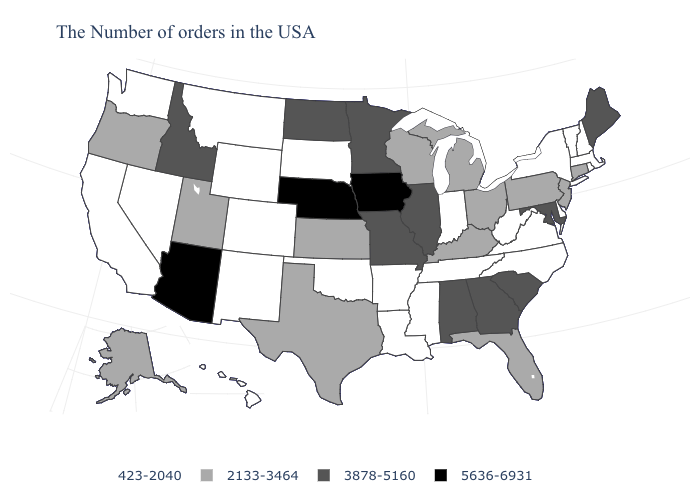What is the value of Michigan?
Answer briefly. 2133-3464. What is the value of Washington?
Write a very short answer. 423-2040. Among the states that border Utah , does Colorado have the highest value?
Concise answer only. No. Name the states that have a value in the range 2133-3464?
Quick response, please. Connecticut, New Jersey, Pennsylvania, Ohio, Florida, Michigan, Kentucky, Wisconsin, Kansas, Texas, Utah, Oregon, Alaska. Name the states that have a value in the range 423-2040?
Concise answer only. Massachusetts, Rhode Island, New Hampshire, Vermont, New York, Delaware, Virginia, North Carolina, West Virginia, Indiana, Tennessee, Mississippi, Louisiana, Arkansas, Oklahoma, South Dakota, Wyoming, Colorado, New Mexico, Montana, Nevada, California, Washington, Hawaii. What is the value of West Virginia?
Write a very short answer. 423-2040. What is the value of Connecticut?
Short answer required. 2133-3464. Does the first symbol in the legend represent the smallest category?
Keep it brief. Yes. What is the highest value in the USA?
Concise answer only. 5636-6931. What is the lowest value in the West?
Concise answer only. 423-2040. Does the map have missing data?
Write a very short answer. No. Which states hav the highest value in the West?
Quick response, please. Arizona. What is the highest value in states that border Oklahoma?
Keep it brief. 3878-5160. Name the states that have a value in the range 423-2040?
Answer briefly. Massachusetts, Rhode Island, New Hampshire, Vermont, New York, Delaware, Virginia, North Carolina, West Virginia, Indiana, Tennessee, Mississippi, Louisiana, Arkansas, Oklahoma, South Dakota, Wyoming, Colorado, New Mexico, Montana, Nevada, California, Washington, Hawaii. 